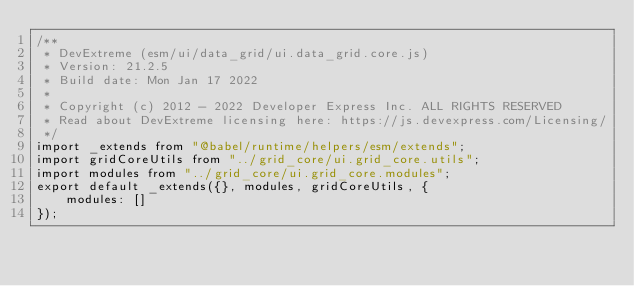<code> <loc_0><loc_0><loc_500><loc_500><_JavaScript_>/**
 * DevExtreme (esm/ui/data_grid/ui.data_grid.core.js)
 * Version: 21.2.5
 * Build date: Mon Jan 17 2022
 *
 * Copyright (c) 2012 - 2022 Developer Express Inc. ALL RIGHTS RESERVED
 * Read about DevExtreme licensing here: https://js.devexpress.com/Licensing/
 */
import _extends from "@babel/runtime/helpers/esm/extends";
import gridCoreUtils from "../grid_core/ui.grid_core.utils";
import modules from "../grid_core/ui.grid_core.modules";
export default _extends({}, modules, gridCoreUtils, {
    modules: []
});
</code> 